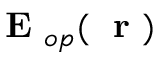<formula> <loc_0><loc_0><loc_500><loc_500>{ E } _ { o p } ( r )</formula> 